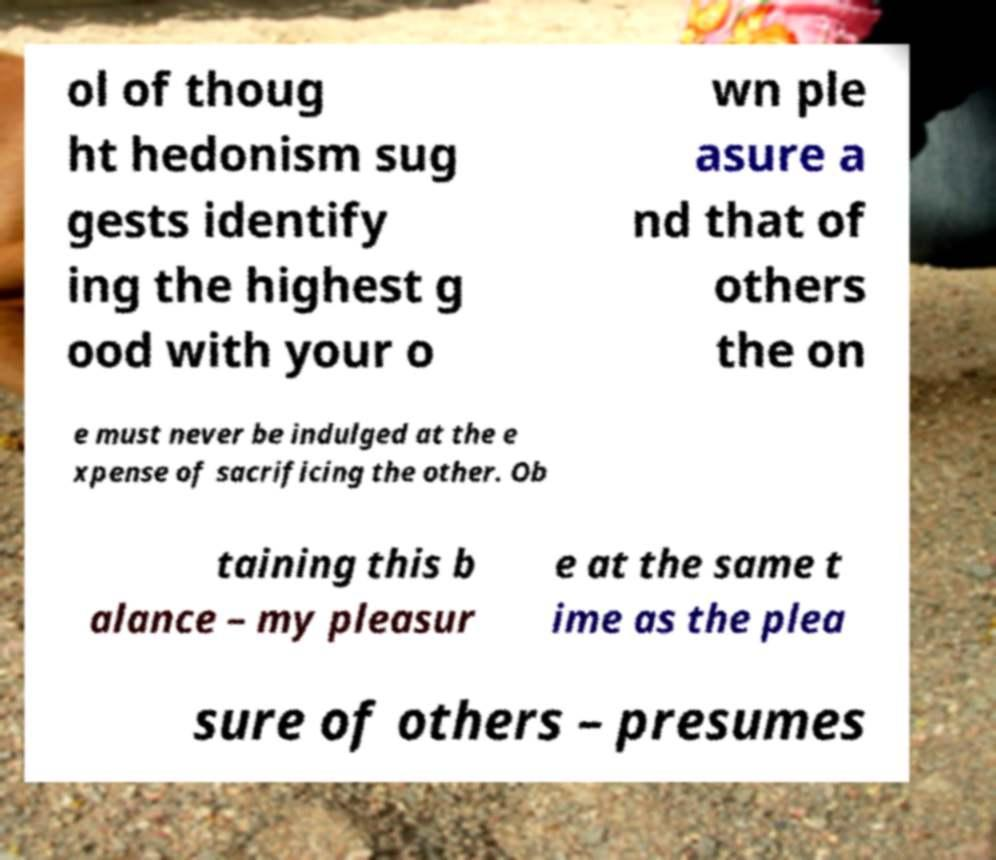There's text embedded in this image that I need extracted. Can you transcribe it verbatim? ol of thoug ht hedonism sug gests identify ing the highest g ood with your o wn ple asure a nd that of others the on e must never be indulged at the e xpense of sacrificing the other. Ob taining this b alance – my pleasur e at the same t ime as the plea sure of others – presumes 